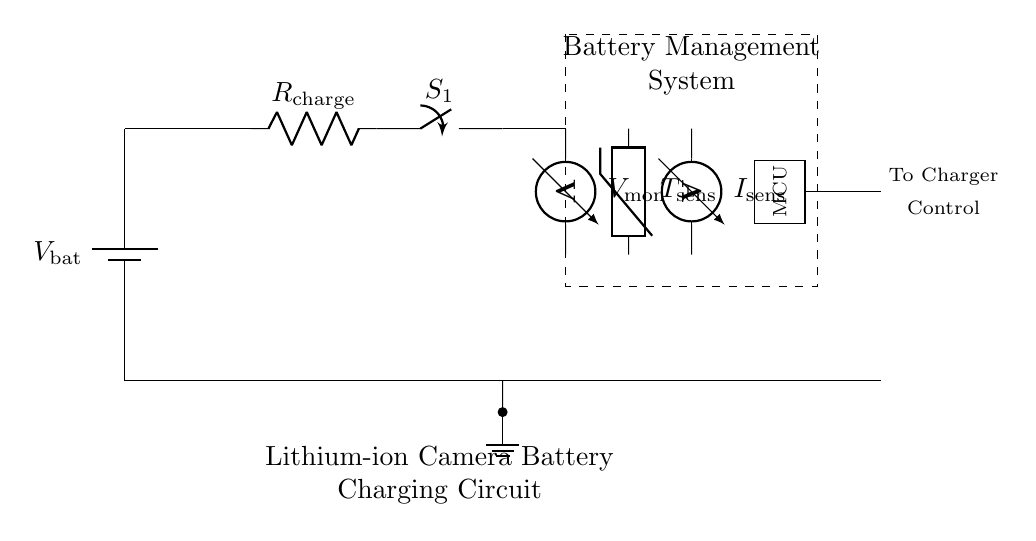What is the type of battery used in this circuit? The circuit uses a lithium-ion battery, as indicated in the title and context of the circuit diagram related to camera batteries.
Answer: lithium-ion What component measures voltage in the circuit? The voltage is monitored by a voltmeter, which is clearly labeled in the diagram, connected after the switch in the circuit path.
Answer: voltmeter What is the function of the thermistor in this circuit? The thermistor is used to monitor temperature, which is crucial for maintaining battery health by preventing overheating during the charging process.
Answer: monitor temperature Which component represents the battery management system? The dashed rectangle surrounding certain components is labeled as the Battery Management System, which is key to optimizing charge and ensuring battery safety.
Answer: Battery Management System What does "R_charge" represent in the circuit? "R_charge" is the resistor used in the charging circuit to limit the amount of current that flows into the battery, helping to manage the charging rate effectively.
Answer: resistor What is the role of the microcontroller (MCU) in the circuit? The microcontroller (MCU) manages the overall operation of the battery management system, processing data from sensors and controlling the charger based on that information.
Answer: manage operation What is the purpose of the switch (S1) in the circuit? The switch (S1) allows manual control to connect or disconnect the charging circuit from the battery management system, enabling or disabling the charging process.
Answer: control charging 